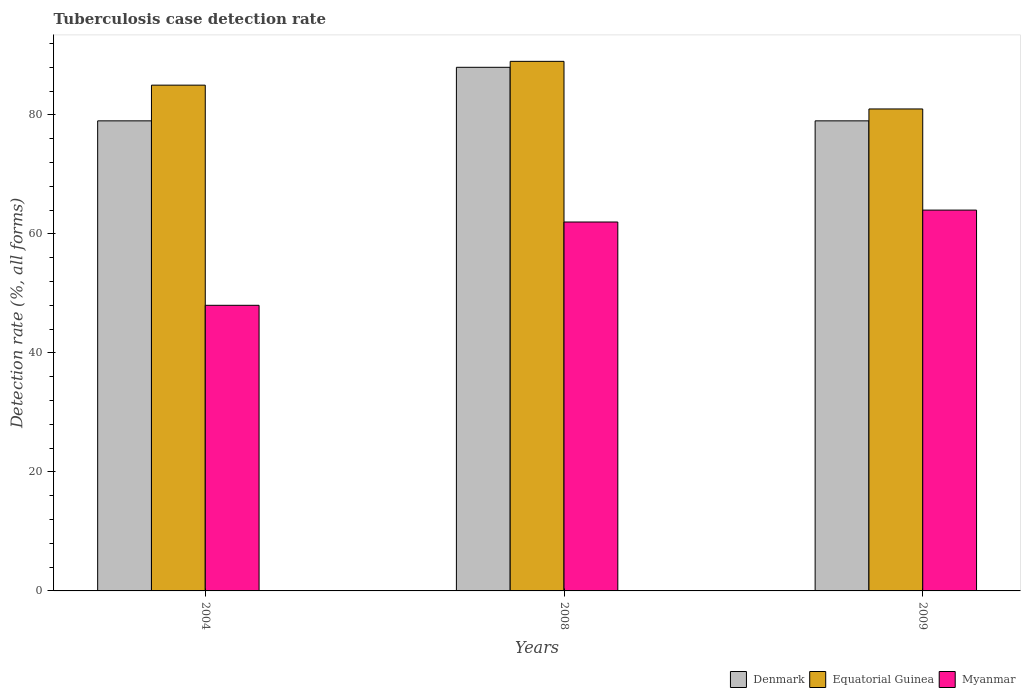How many different coloured bars are there?
Your response must be concise. 3. Are the number of bars per tick equal to the number of legend labels?
Make the answer very short. Yes. Are the number of bars on each tick of the X-axis equal?
Give a very brief answer. Yes. How many bars are there on the 1st tick from the right?
Your answer should be compact. 3. What is the label of the 3rd group of bars from the left?
Give a very brief answer. 2009. What is the tuberculosis case detection rate in in Equatorial Guinea in 2004?
Keep it short and to the point. 85. In which year was the tuberculosis case detection rate in in Equatorial Guinea maximum?
Provide a succinct answer. 2008. What is the total tuberculosis case detection rate in in Myanmar in the graph?
Offer a terse response. 174. In the year 2009, what is the difference between the tuberculosis case detection rate in in Denmark and tuberculosis case detection rate in in Equatorial Guinea?
Offer a terse response. -2. In how many years, is the tuberculosis case detection rate in in Myanmar greater than 20 %?
Provide a short and direct response. 3. What is the ratio of the tuberculosis case detection rate in in Equatorial Guinea in 2008 to that in 2009?
Give a very brief answer. 1.1. Is the tuberculosis case detection rate in in Myanmar in 2008 less than that in 2009?
Provide a short and direct response. Yes. Is the difference between the tuberculosis case detection rate in in Denmark in 2004 and 2009 greater than the difference between the tuberculosis case detection rate in in Equatorial Guinea in 2004 and 2009?
Provide a short and direct response. No. What is the difference between the highest and the second highest tuberculosis case detection rate in in Denmark?
Your response must be concise. 9. In how many years, is the tuberculosis case detection rate in in Equatorial Guinea greater than the average tuberculosis case detection rate in in Equatorial Guinea taken over all years?
Provide a short and direct response. 1. Are the values on the major ticks of Y-axis written in scientific E-notation?
Make the answer very short. No. Does the graph contain any zero values?
Your answer should be compact. No. Where does the legend appear in the graph?
Offer a very short reply. Bottom right. How are the legend labels stacked?
Your answer should be compact. Horizontal. What is the title of the graph?
Offer a very short reply. Tuberculosis case detection rate. Does "Cambodia" appear as one of the legend labels in the graph?
Your answer should be very brief. No. What is the label or title of the Y-axis?
Offer a terse response. Detection rate (%, all forms). What is the Detection rate (%, all forms) of Denmark in 2004?
Your response must be concise. 79. What is the Detection rate (%, all forms) of Equatorial Guinea in 2004?
Offer a very short reply. 85. What is the Detection rate (%, all forms) in Equatorial Guinea in 2008?
Offer a very short reply. 89. What is the Detection rate (%, all forms) of Denmark in 2009?
Offer a very short reply. 79. Across all years, what is the maximum Detection rate (%, all forms) in Equatorial Guinea?
Your response must be concise. 89. Across all years, what is the maximum Detection rate (%, all forms) of Myanmar?
Provide a succinct answer. 64. Across all years, what is the minimum Detection rate (%, all forms) in Denmark?
Keep it short and to the point. 79. What is the total Detection rate (%, all forms) of Denmark in the graph?
Ensure brevity in your answer.  246. What is the total Detection rate (%, all forms) in Equatorial Guinea in the graph?
Offer a very short reply. 255. What is the total Detection rate (%, all forms) in Myanmar in the graph?
Your response must be concise. 174. What is the difference between the Detection rate (%, all forms) of Denmark in 2004 and that in 2008?
Offer a terse response. -9. What is the difference between the Detection rate (%, all forms) in Equatorial Guinea in 2004 and that in 2008?
Offer a terse response. -4. What is the difference between the Detection rate (%, all forms) in Denmark in 2004 and that in 2009?
Your answer should be compact. 0. What is the difference between the Detection rate (%, all forms) in Equatorial Guinea in 2008 and that in 2009?
Give a very brief answer. 8. What is the difference between the Detection rate (%, all forms) of Denmark in 2004 and the Detection rate (%, all forms) of Myanmar in 2008?
Offer a terse response. 17. What is the difference between the Detection rate (%, all forms) of Equatorial Guinea in 2004 and the Detection rate (%, all forms) of Myanmar in 2008?
Keep it short and to the point. 23. What is the difference between the Detection rate (%, all forms) of Denmark in 2004 and the Detection rate (%, all forms) of Equatorial Guinea in 2009?
Keep it short and to the point. -2. What is the difference between the Detection rate (%, all forms) in Denmark in 2004 and the Detection rate (%, all forms) in Myanmar in 2009?
Keep it short and to the point. 15. What is the difference between the Detection rate (%, all forms) in Denmark in 2008 and the Detection rate (%, all forms) in Equatorial Guinea in 2009?
Offer a terse response. 7. What is the difference between the Detection rate (%, all forms) in Equatorial Guinea in 2008 and the Detection rate (%, all forms) in Myanmar in 2009?
Give a very brief answer. 25. What is the average Detection rate (%, all forms) in Denmark per year?
Give a very brief answer. 82. In the year 2009, what is the difference between the Detection rate (%, all forms) of Denmark and Detection rate (%, all forms) of Myanmar?
Make the answer very short. 15. In the year 2009, what is the difference between the Detection rate (%, all forms) of Equatorial Guinea and Detection rate (%, all forms) of Myanmar?
Your answer should be very brief. 17. What is the ratio of the Detection rate (%, all forms) in Denmark in 2004 to that in 2008?
Your answer should be very brief. 0.9. What is the ratio of the Detection rate (%, all forms) of Equatorial Guinea in 2004 to that in 2008?
Make the answer very short. 0.96. What is the ratio of the Detection rate (%, all forms) of Myanmar in 2004 to that in 2008?
Offer a terse response. 0.77. What is the ratio of the Detection rate (%, all forms) of Denmark in 2004 to that in 2009?
Offer a very short reply. 1. What is the ratio of the Detection rate (%, all forms) of Equatorial Guinea in 2004 to that in 2009?
Your response must be concise. 1.05. What is the ratio of the Detection rate (%, all forms) in Denmark in 2008 to that in 2009?
Offer a terse response. 1.11. What is the ratio of the Detection rate (%, all forms) in Equatorial Guinea in 2008 to that in 2009?
Your answer should be very brief. 1.1. What is the ratio of the Detection rate (%, all forms) in Myanmar in 2008 to that in 2009?
Ensure brevity in your answer.  0.97. What is the difference between the highest and the second highest Detection rate (%, all forms) in Equatorial Guinea?
Your response must be concise. 4. What is the difference between the highest and the lowest Detection rate (%, all forms) in Equatorial Guinea?
Keep it short and to the point. 8. 